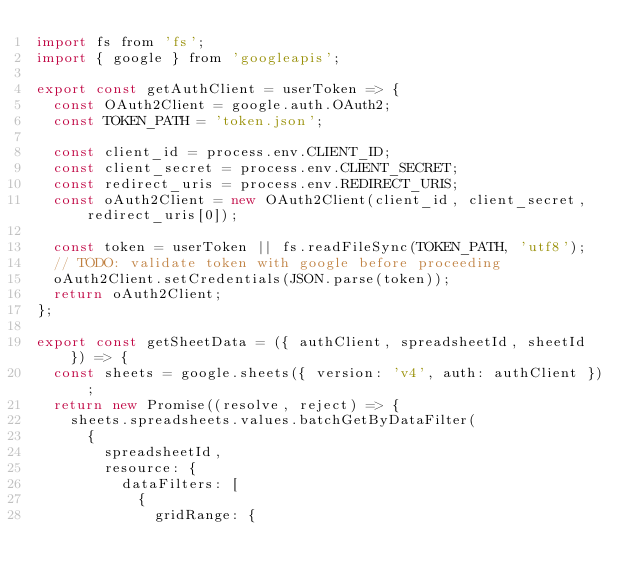<code> <loc_0><loc_0><loc_500><loc_500><_JavaScript_>import fs from 'fs';
import { google } from 'googleapis';

export const getAuthClient = userToken => {
  const OAuth2Client = google.auth.OAuth2;
  const TOKEN_PATH = 'token.json';

  const client_id = process.env.CLIENT_ID;
  const client_secret = process.env.CLIENT_SECRET;
  const redirect_uris = process.env.REDIRECT_URIS;
  const oAuth2Client = new OAuth2Client(client_id, client_secret, redirect_uris[0]);

  const token = userToken || fs.readFileSync(TOKEN_PATH, 'utf8');
  // TODO: validate token with google before proceeding
  oAuth2Client.setCredentials(JSON.parse(token));
  return oAuth2Client;
};

export const getSheetData = ({ authClient, spreadsheetId, sheetId }) => {
  const sheets = google.sheets({ version: 'v4', auth: authClient });
  return new Promise((resolve, reject) => {
    sheets.spreadsheets.values.batchGetByDataFilter(
      {
        spreadsheetId,
        resource: {
          dataFilters: [
            {
              gridRange: {</code> 